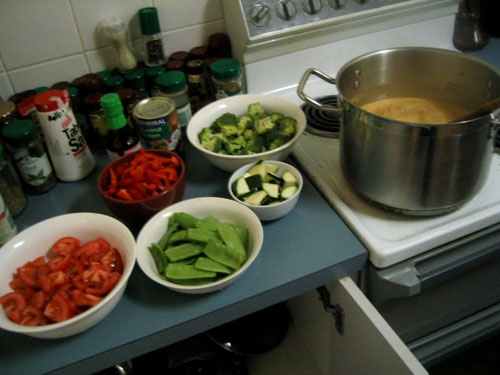Describe the objects in this image and their specific colors. I can see oven in gray, black, darkgray, and darkgreen tones, oven in gray, black, and purple tones, bowl in gray, maroon, darkgray, and lightgray tones, bowl in gray, darkgreen, olive, black, and lightgray tones, and bowl in gray, darkgreen, black, olive, and lightgray tones in this image. 